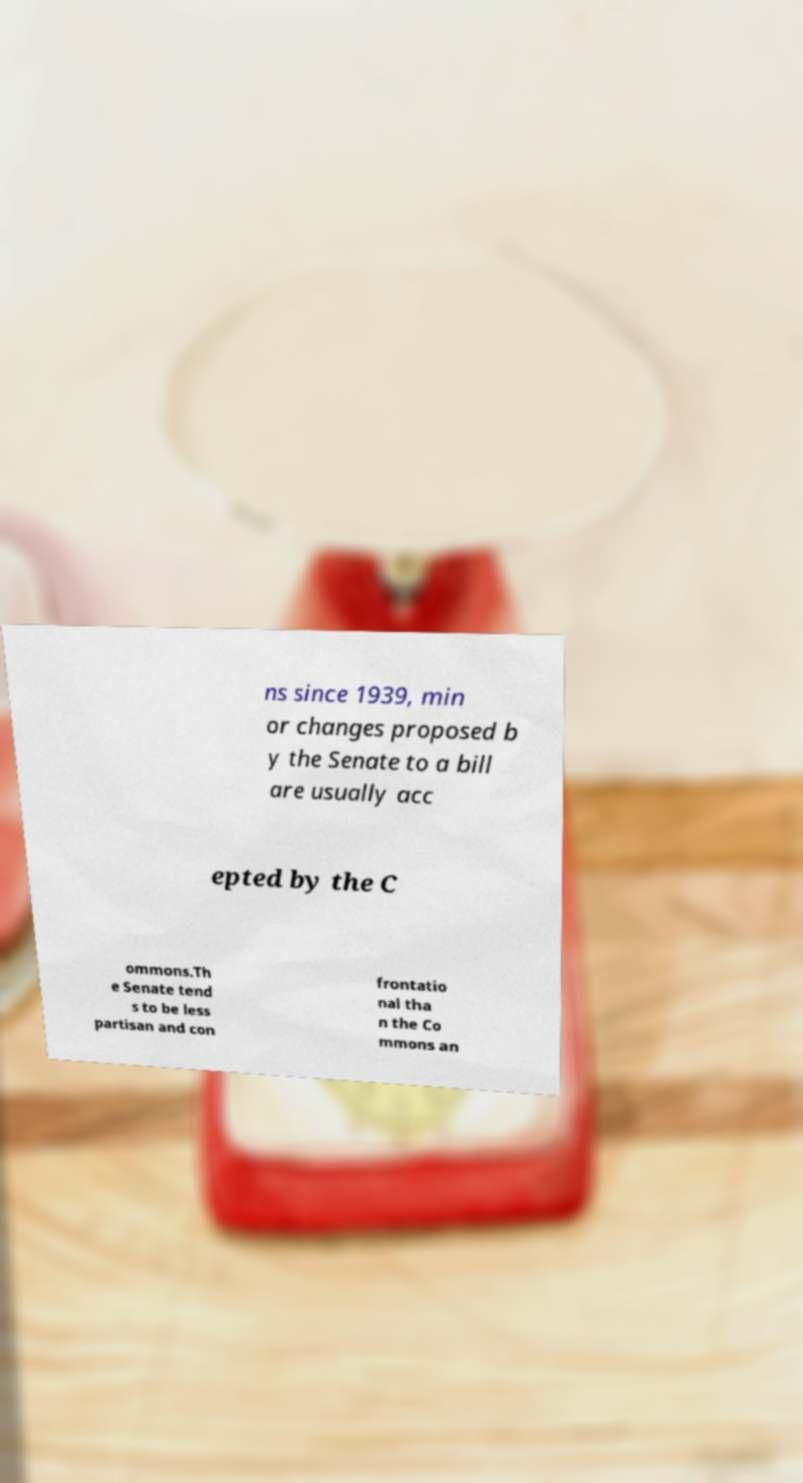Could you extract and type out the text from this image? ns since 1939, min or changes proposed b y the Senate to a bill are usually acc epted by the C ommons.Th e Senate tend s to be less partisan and con frontatio nal tha n the Co mmons an 